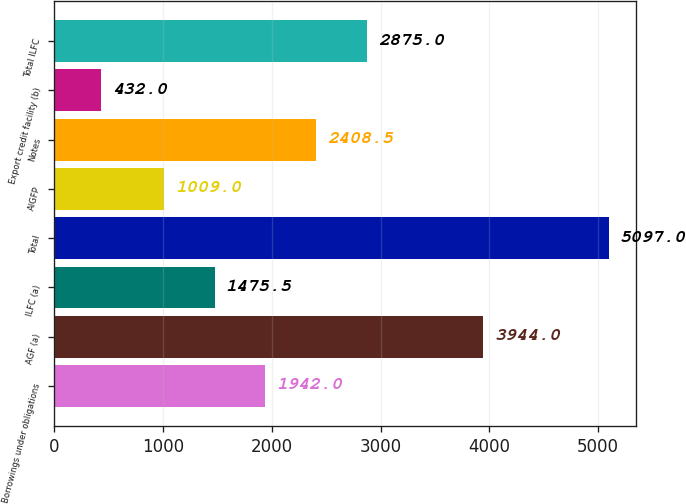Convert chart to OTSL. <chart><loc_0><loc_0><loc_500><loc_500><bar_chart><fcel>Borrowings under obligations<fcel>AGF (a)<fcel>ILFC (a)<fcel>Total<fcel>AIGFP<fcel>Notes<fcel>Export credit facility (b)<fcel>Total ILFC<nl><fcel>1942<fcel>3944<fcel>1475.5<fcel>5097<fcel>1009<fcel>2408.5<fcel>432<fcel>2875<nl></chart> 